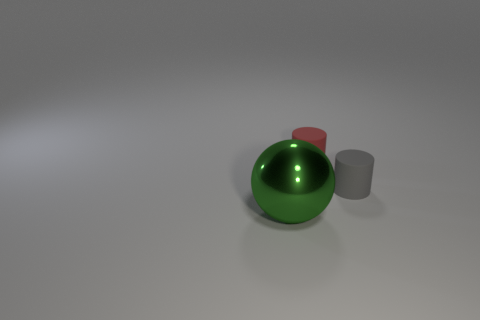Add 3 large green matte blocks. How many objects exist? 6 Add 3 big gray cylinders. How many big gray cylinders exist? 3 Subtract 0 purple cubes. How many objects are left? 3 Subtract all balls. How many objects are left? 2 Subtract all brown spheres. Subtract all yellow cylinders. How many spheres are left? 1 Subtract all tiny red matte things. Subtract all gray matte objects. How many objects are left? 1 Add 1 small matte cylinders. How many small matte cylinders are left? 3 